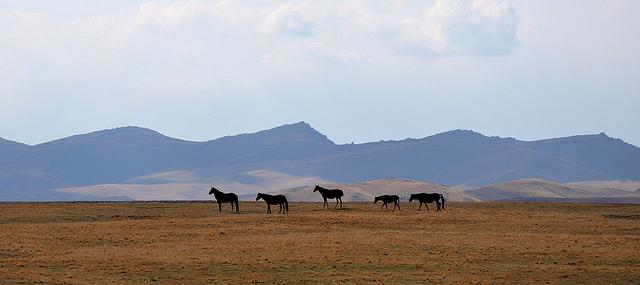Are the mountains high?
Keep it brief. Yes. What is on the mountains?
Give a very brief answer. Trees. What color is the grass?
Write a very short answer. Brown. How many horses are running?
Give a very brief answer. 0. Is the picture old?
Write a very short answer. No. How many horses can you see?
Keep it brief. 5. What are the animals in the field?
Write a very short answer. Horses. What is on top of the mountain?
Give a very brief answer. Trees. How many horses are there?
Keep it brief. 5. How many horses are in the field?
Write a very short answer. 5. Are these race horses?
Keep it brief. No. What is the exact breed of this type of animal?
Keep it brief. Horse. Can any of these animals fly?
Write a very short answer. No. Is there green in this image?
Give a very brief answer. No. What animal do you see?
Be succinct. Horse. Is this area a desert?
Keep it brief. Yes. Any water in the picture?
Give a very brief answer. No. Is it clear outside?
Concise answer only. Yes. What animal is in the picture?
Short answer required. Horse. How many pieces of litter are on the ground?
Write a very short answer. 0. Are the horses in motion?
Short answer required. No. What kind of animal is on the ground?
Short answer required. Horse. What are these animals doing?
Be succinct. Standing. 